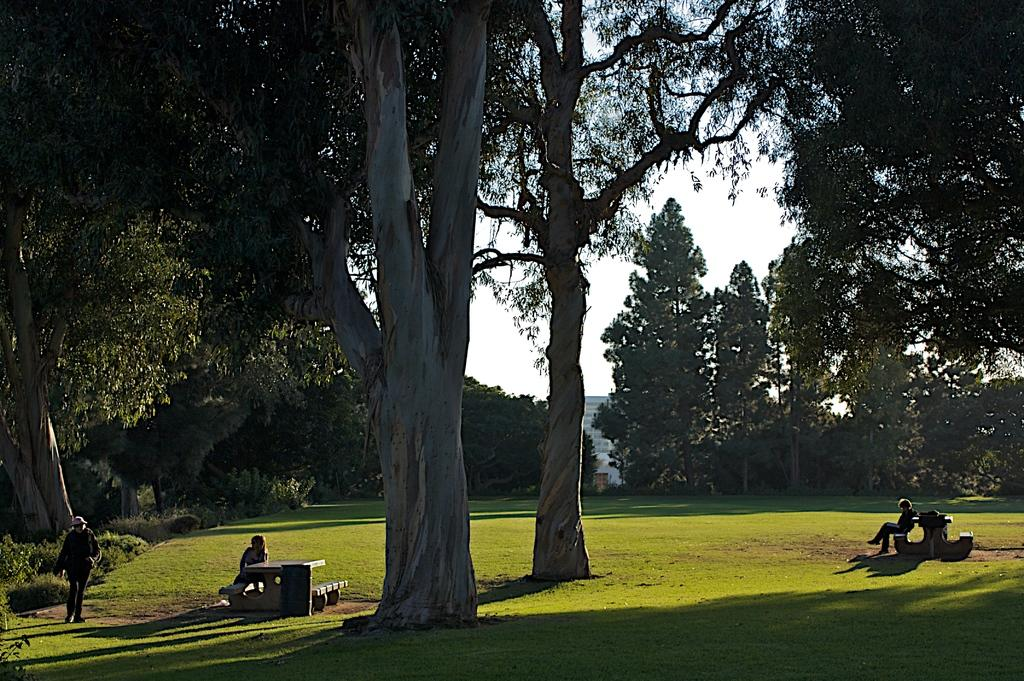How many people are sitting on the bench in the image? There are two persons sitting on a bench in the image. What is the person in the image doing besides sitting on the bench? There is a person walking on the ground in the image. What can be seen in the background of the image? Trees, grass, a building, and the sky are visible in the background of the image. How many apples are being delivered to the person sitting on the bench in the image? There are no apples or delivery mentioned in the image; it only shows two persons sitting on a bench and a person walking on the ground. What type of zipper can be seen on the person walking in the image? There is no zipper visible on the person walking in the image. 